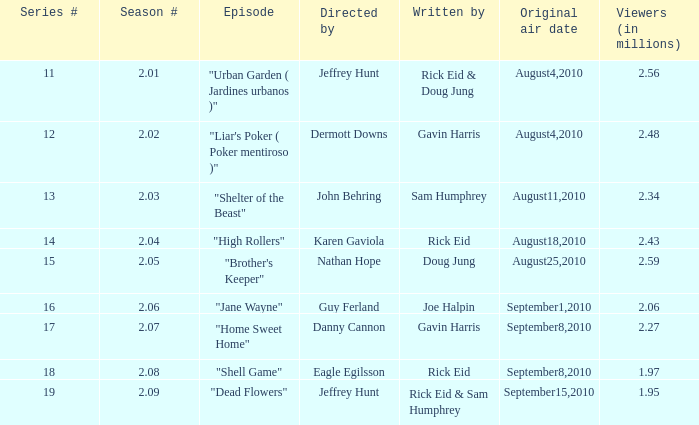If the season number is 2.08, who was the episode written by? Rick Eid. 